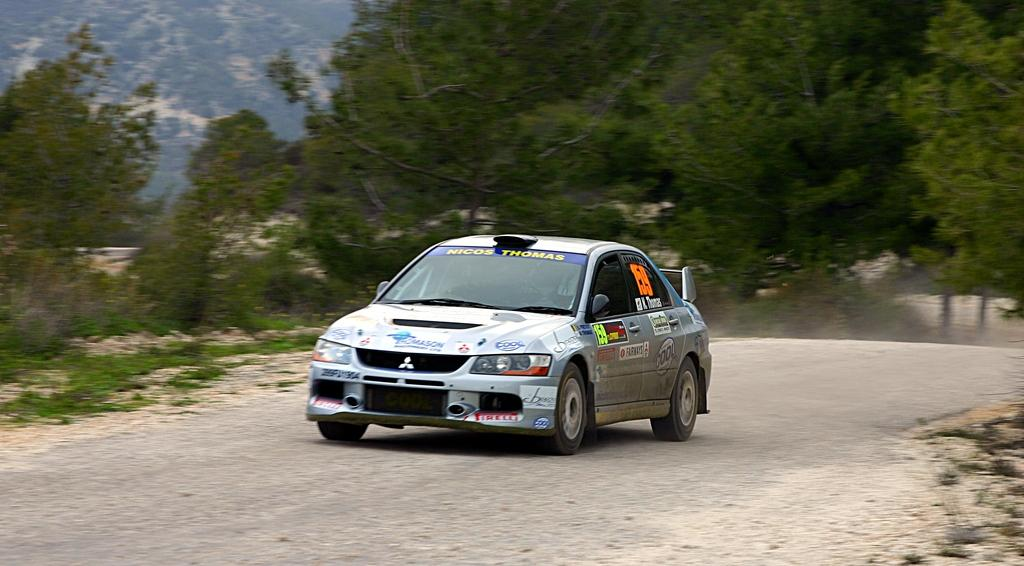What is the main subject of the image? There is a car on the road in the image. What can be seen in the background of the image? There are trees in the background of the image. What is visible in the sky at the top of the image? Clouds are visible in the sky at the top of the image. What word is written on the dock in the image? There is no dock present in the image, so it is not possible to answer that question. 